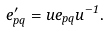Convert formula to latex. <formula><loc_0><loc_0><loc_500><loc_500>e ^ { \prime } _ { p q } = u e _ { p q } u ^ { - 1 } .</formula> 